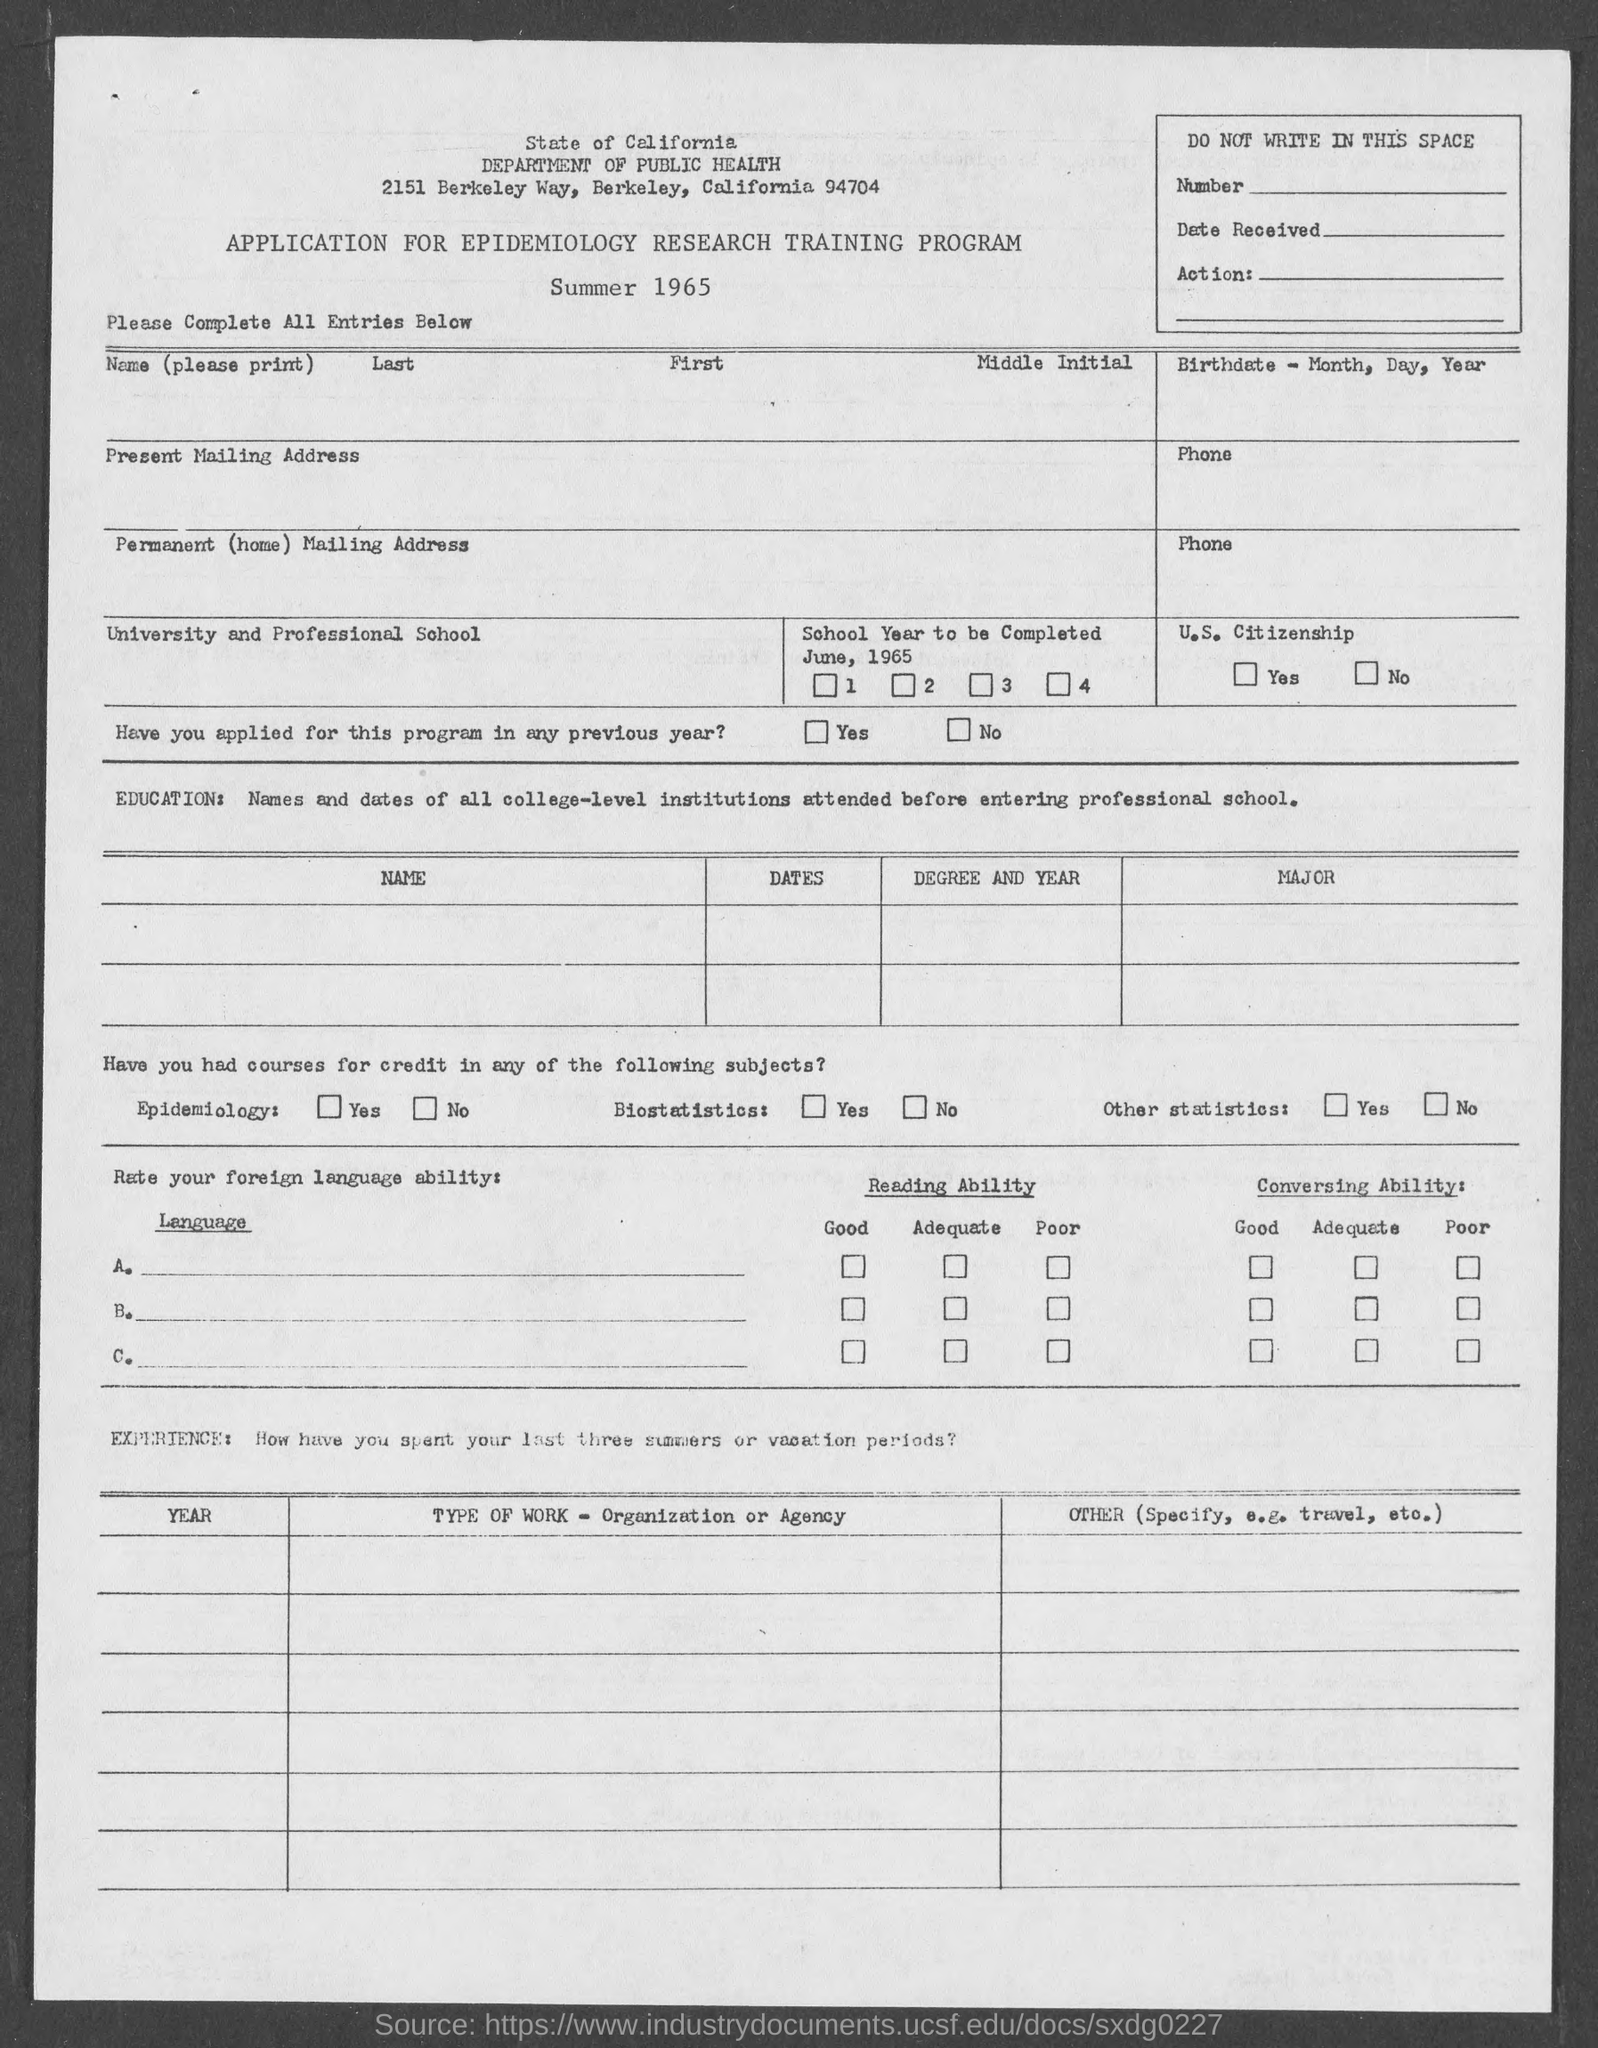Indicate a few pertinent items in this graphic. The State of California Department of Public Health is located in Berkeley, a city in the state of California. 